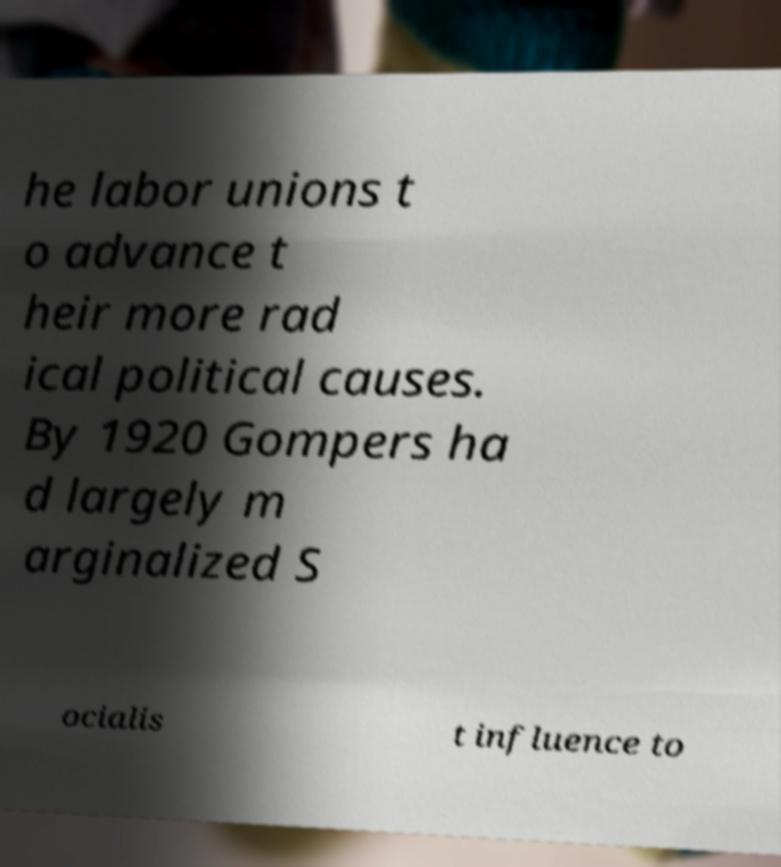What messages or text are displayed in this image? I need them in a readable, typed format. he labor unions t o advance t heir more rad ical political causes. By 1920 Gompers ha d largely m arginalized S ocialis t influence to 